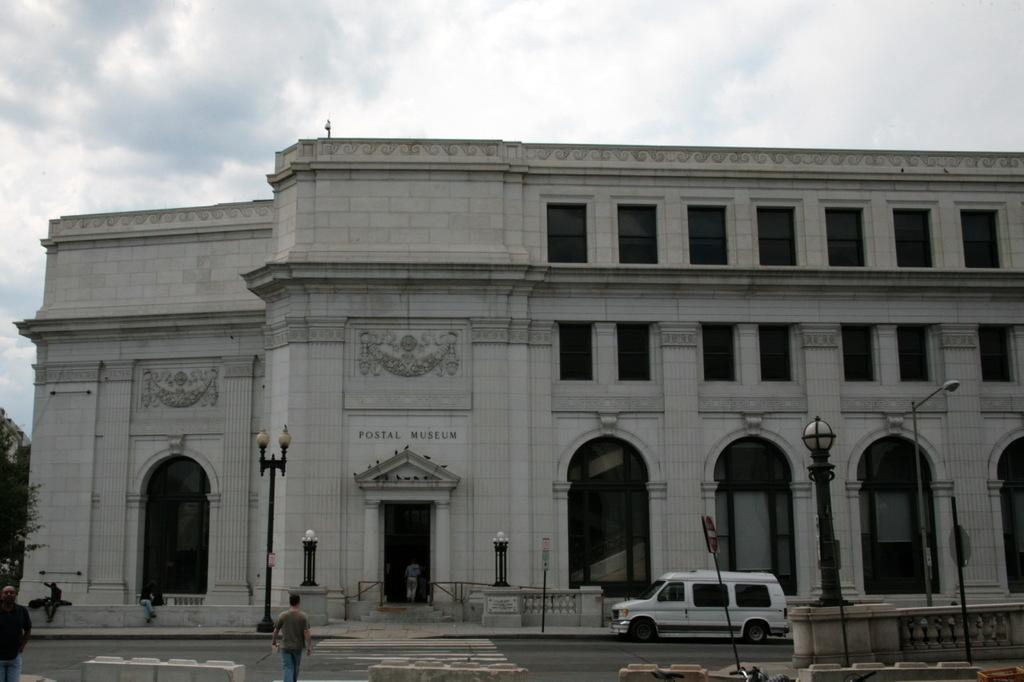<image>
Present a compact description of the photo's key features. Large white building which says Postal Museum on it. 